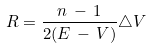<formula> <loc_0><loc_0><loc_500><loc_500>R = \frac { n \, - \, 1 } { 2 ( E \, - \, V ) } \triangle V</formula> 